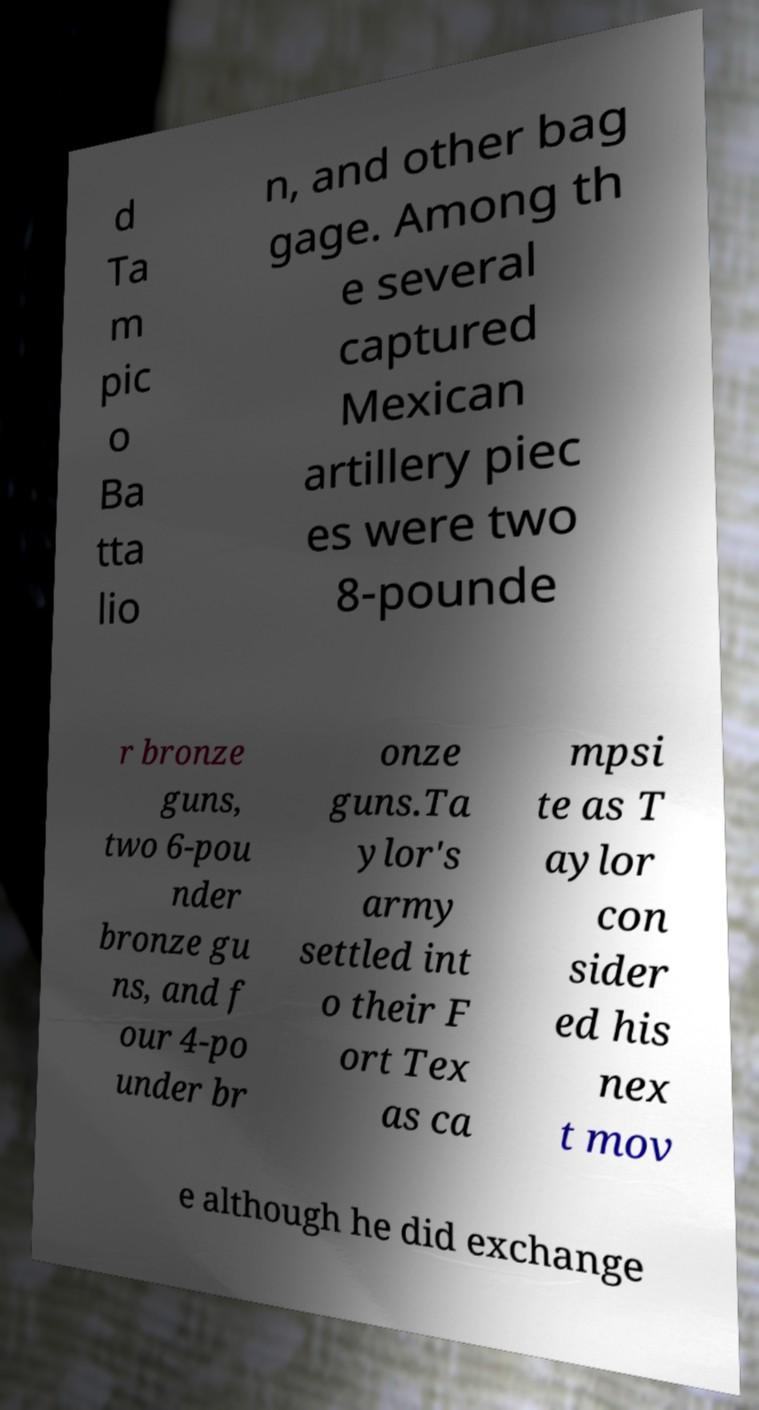For documentation purposes, I need the text within this image transcribed. Could you provide that? d Ta m pic o Ba tta lio n, and other bag gage. Among th e several captured Mexican artillery piec es were two 8-pounde r bronze guns, two 6-pou nder bronze gu ns, and f our 4-po under br onze guns.Ta ylor's army settled int o their F ort Tex as ca mpsi te as T aylor con sider ed his nex t mov e although he did exchange 